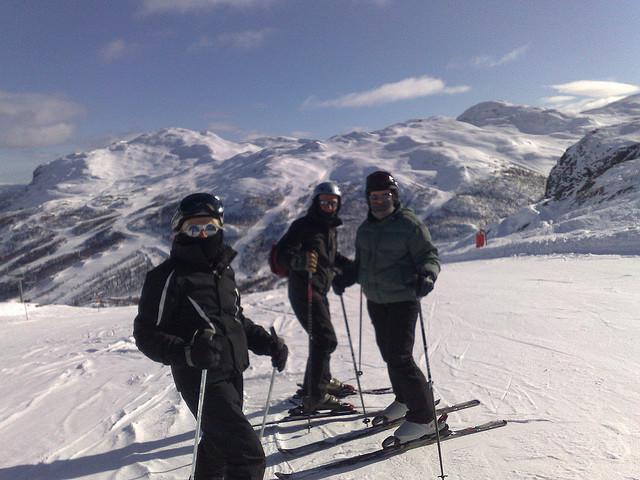Why are these people covering their faces?
Pick the correct solution from the four options below to address the question.
Options: Keeping warm, stopping covid, for style, as punishment. Keeping warm. 